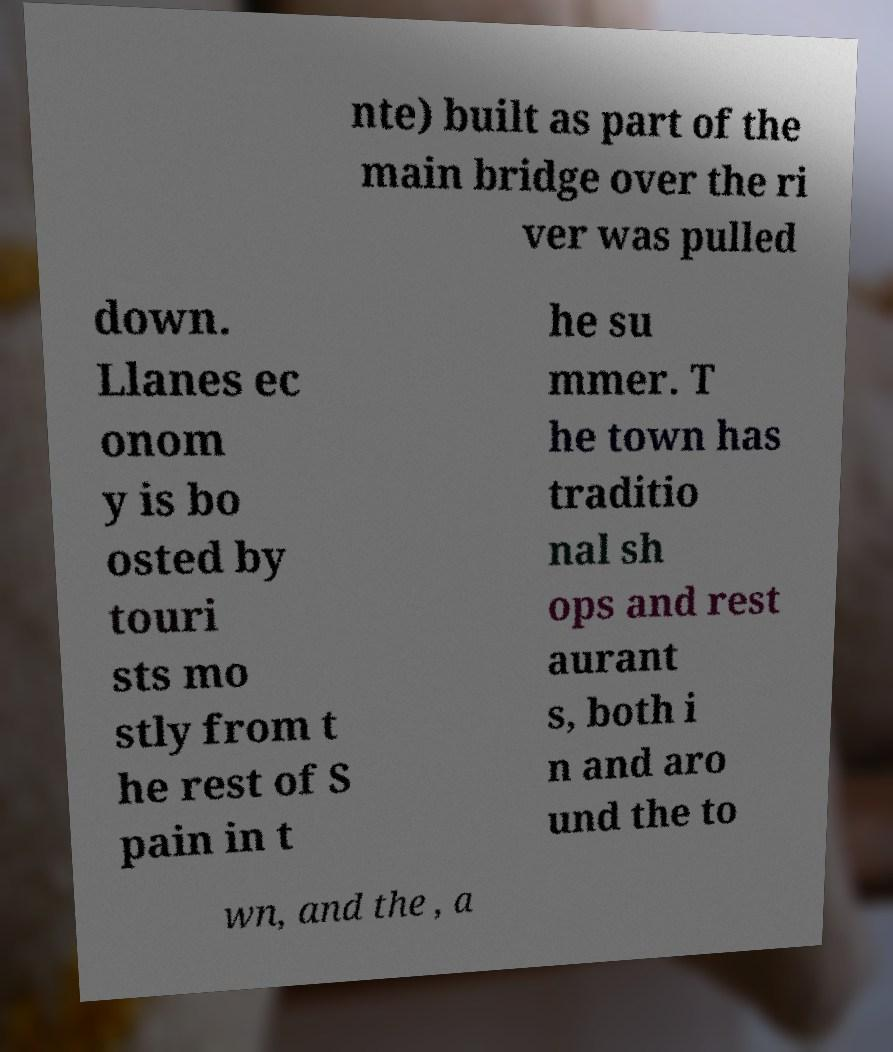Please read and relay the text visible in this image. What does it say? nte) built as part of the main bridge over the ri ver was pulled down. Llanes ec onom y is bo osted by touri sts mo stly from t he rest of S pain in t he su mmer. T he town has traditio nal sh ops and rest aurant s, both i n and aro und the to wn, and the , a 